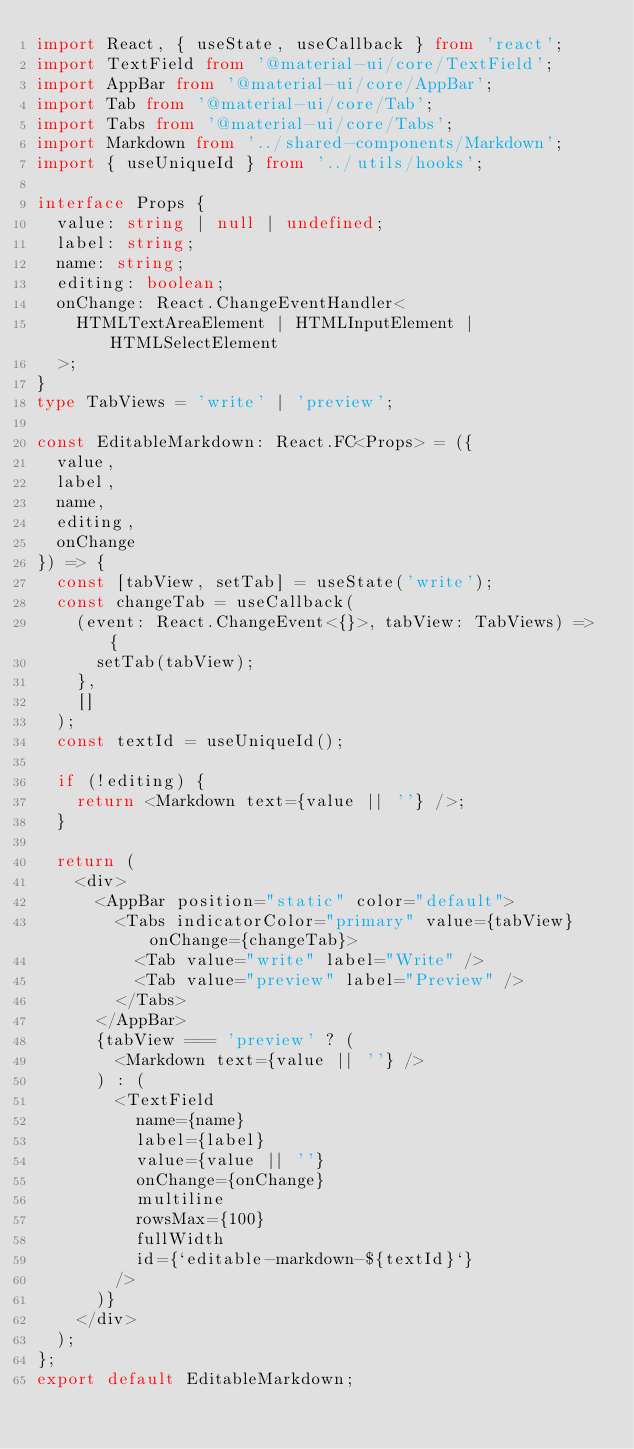Convert code to text. <code><loc_0><loc_0><loc_500><loc_500><_TypeScript_>import React, { useState, useCallback } from 'react';
import TextField from '@material-ui/core/TextField';
import AppBar from '@material-ui/core/AppBar';
import Tab from '@material-ui/core/Tab';
import Tabs from '@material-ui/core/Tabs';
import Markdown from '../shared-components/Markdown';
import { useUniqueId } from '../utils/hooks';

interface Props {
  value: string | null | undefined;
  label: string;
  name: string;
  editing: boolean;
  onChange: React.ChangeEventHandler<
    HTMLTextAreaElement | HTMLInputElement | HTMLSelectElement
  >;
}
type TabViews = 'write' | 'preview';

const EditableMarkdown: React.FC<Props> = ({
  value,
  label,
  name,
  editing,
  onChange
}) => {
  const [tabView, setTab] = useState('write');
  const changeTab = useCallback(
    (event: React.ChangeEvent<{}>, tabView: TabViews) => {
      setTab(tabView);
    },
    []
  );
  const textId = useUniqueId();

  if (!editing) {
    return <Markdown text={value || ''} />;
  }

  return (
    <div>
      <AppBar position="static" color="default">
        <Tabs indicatorColor="primary" value={tabView} onChange={changeTab}>
          <Tab value="write" label="Write" />
          <Tab value="preview" label="Preview" />
        </Tabs>
      </AppBar>
      {tabView === 'preview' ? (
        <Markdown text={value || ''} />
      ) : (
        <TextField
          name={name}
          label={label}
          value={value || ''}
          onChange={onChange}
          multiline
          rowsMax={100}
          fullWidth
          id={`editable-markdown-${textId}`}
        />
      )}
    </div>
  );
};
export default EditableMarkdown;
</code> 